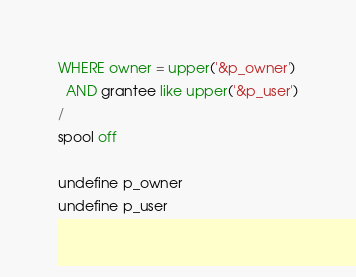Convert code to text. <code><loc_0><loc_0><loc_500><loc_500><_SQL_>WHERE owner = upper('&p_owner')
  AND grantee like upper('&p_user')
/
spool off

undefine p_owner
undefine p_user
</code> 